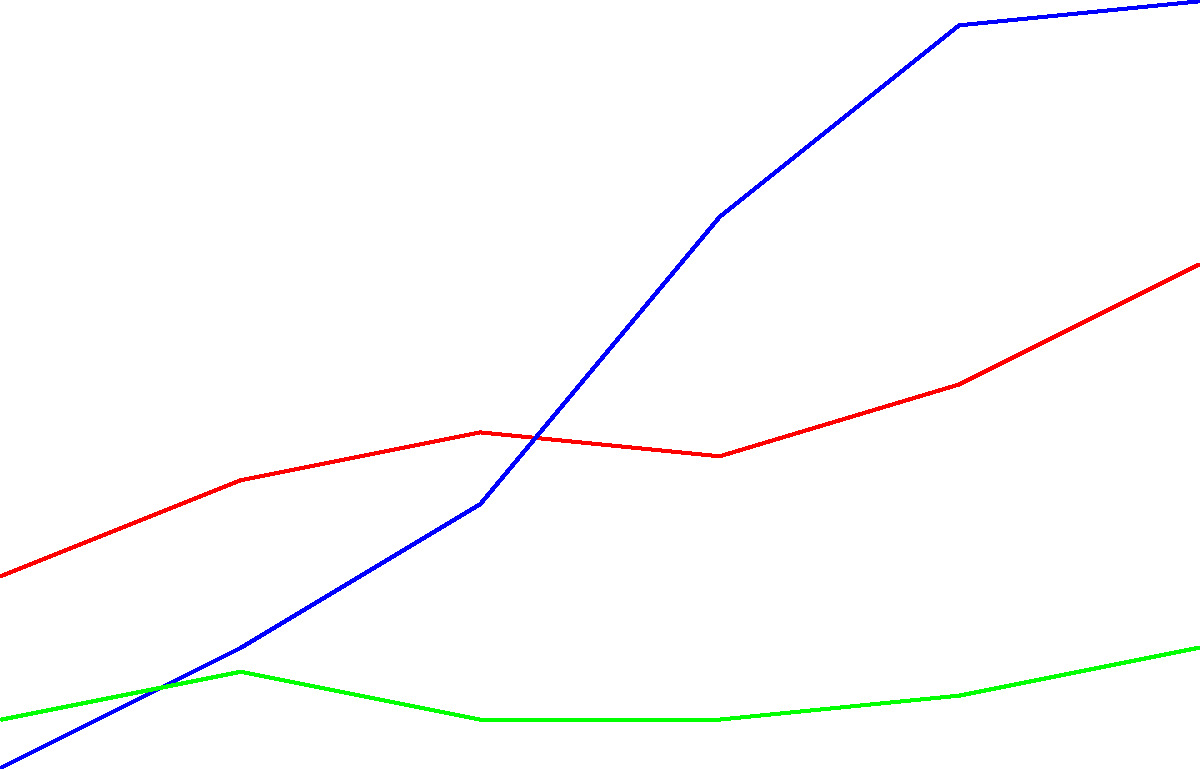Looking at the milk production trends over the past 50 years, which state has shown the most significant increase, and approximately how many billion pounds did its production grow between 1970 and 2020? To answer this question, we need to analyze the milk production trends for each state shown in the graph:

1. Wisconsin (red line):
   - 1970: 18 billion pounds
   - 2020: 31 billion pounds
   - Increase: 31 - 18 = 13 billion pounds

2. California (blue line):
   - 1970: 10 billion pounds
   - 2020: 42 billion pounds
   - Increase: 42 - 10 = 32 billion pounds

3. New York (green line):
   - 1970: 12 billion pounds
   - 2020: 15 billion pounds
   - Increase: 15 - 12 = 3 billion pounds

Comparing these increases, we can see that California has shown the most significant growth in milk production over the past 50 years. The increase for California is approximately 32 billion pounds.
Answer: California, 32 billion pounds 